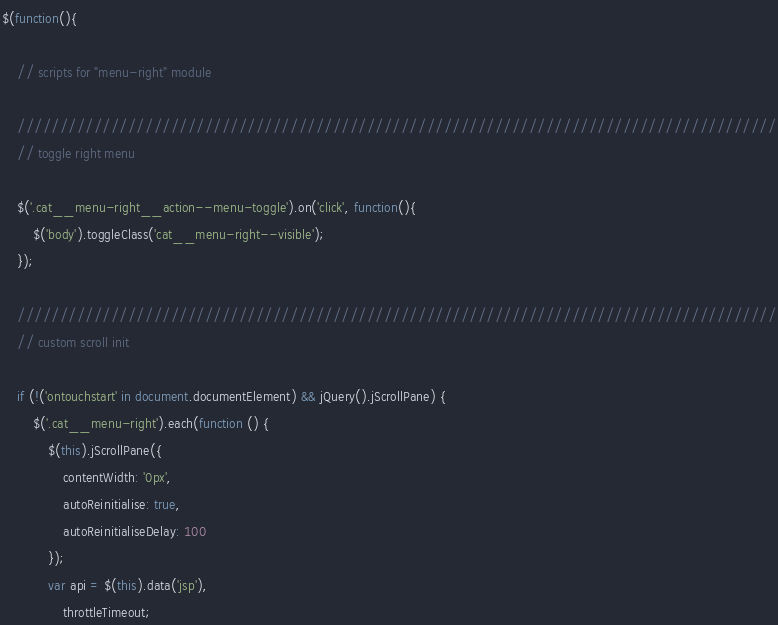<code> <loc_0><loc_0><loc_500><loc_500><_JavaScript_>$(function(){

    // scripts for "menu-right" module

    /////////////////////////////////////////////////////////////////////////////////////////
    // toggle right menu

    $('.cat__menu-right__action--menu-toggle').on('click', function(){
        $('body').toggleClass('cat__menu-right--visible');
    });

    /////////////////////////////////////////////////////////////////////////////////////////
    // custom scroll init

    if (!('ontouchstart' in document.documentElement) && jQuery().jScrollPane) {
        $('.cat__menu-right').each(function () {
            $(this).jScrollPane({
                contentWidth: '0px',
                autoReinitialise: true,
                autoReinitialiseDelay: 100
            });
            var api = $(this).data('jsp'),
                throttleTimeout;</code> 